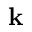<formula> <loc_0><loc_0><loc_500><loc_500>{ k }</formula> 